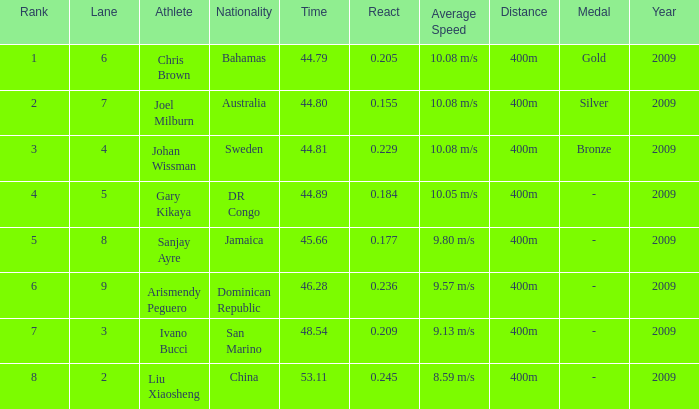How many total Rank listings have Liu Xiaosheng listed as the athlete with a react entry that is smaller than 0.245? 0.0. 